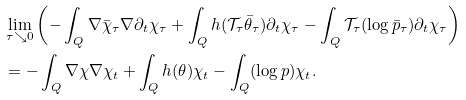<formula> <loc_0><loc_0><loc_500><loc_500>& \lim _ { \tau \searrow 0 } \left ( - \int _ { Q } \nabla \bar { \chi } _ { \tau } \nabla \partial _ { t } \chi _ { \tau } + \int _ { Q } h ( \mathcal { T _ { \tau } } \bar { \theta } _ { \tau } ) \partial _ { t } \chi _ { \tau } - \int _ { Q } \mathcal { T _ { \tau } } ( \log \bar { p } _ { \tau } ) \partial _ { t } \chi _ { \tau } \right ) \\ & = - \int _ { Q } \nabla \chi \nabla \chi _ { t } + \int _ { Q } h ( \theta ) \chi _ { t } - \int _ { Q } ( \log p ) \chi _ { t } .</formula> 